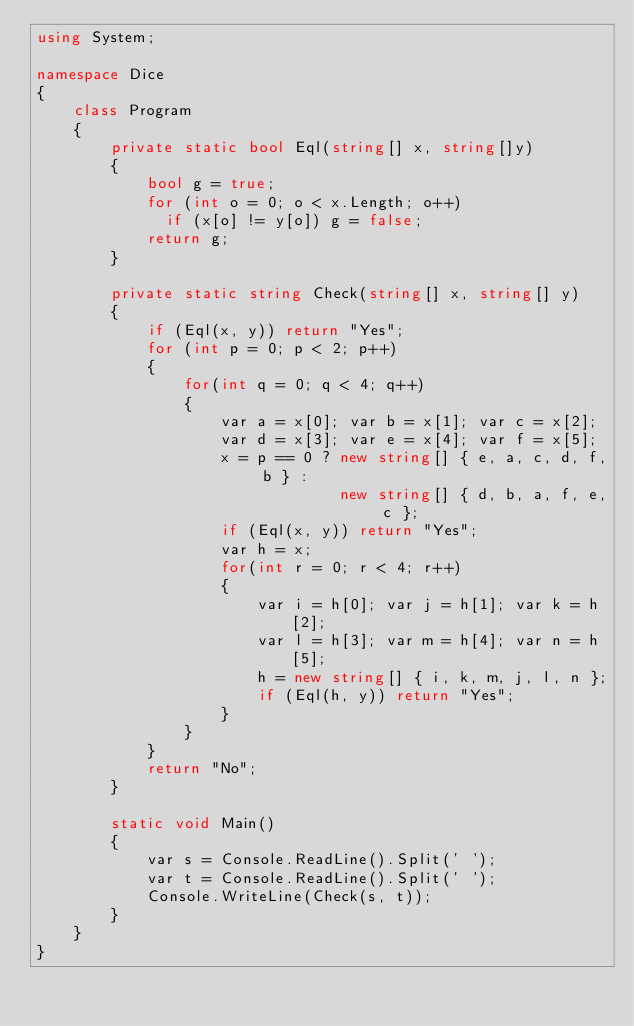<code> <loc_0><loc_0><loc_500><loc_500><_C#_>using System;

namespace Dice
{
    class Program
    {
        private static bool Eql(string[] x, string[]y)
        {
            bool g = true;
            for (int o = 0; o < x.Length; o++)
              if (x[o] != y[o]) g = false;
            return g;
        }

        private static string Check(string[] x, string[] y)
        {
            if (Eql(x, y)) return "Yes";
            for (int p = 0; p < 2; p++)
            {
                for(int q = 0; q < 4; q++)
                {
                    var a = x[0]; var b = x[1]; var c = x[2];
                    var d = x[3]; var e = x[4]; var f = x[5];
                    x = p == 0 ? new string[] { e, a, c, d, f, b } :
                                 new string[] { d, b, a, f, e, c };
                    if (Eql(x, y)) return "Yes";
                    var h = x;
                    for(int r = 0; r < 4; r++)
                    {
                        var i = h[0]; var j = h[1]; var k = h[2];
                        var l = h[3]; var m = h[4]; var n = h[5];
                        h = new string[] { i, k, m, j, l, n };
                        if (Eql(h, y)) return "Yes";
                    }
                }
            }
            return "No";
        }

        static void Main()
        {
            var s = Console.ReadLine().Split(' ');
            var t = Console.ReadLine().Split(' ');
            Console.WriteLine(Check(s, t));
        }
    }
}</code> 